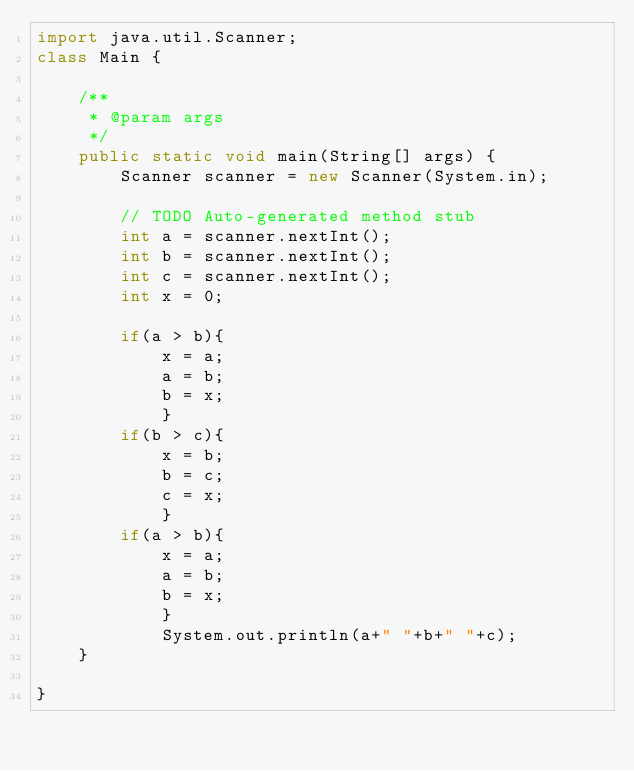<code> <loc_0><loc_0><loc_500><loc_500><_Java_>import java.util.Scanner;
class Main {
          
    /**
     * @param args
     */
    public static void main(String[] args) {
        Scanner scanner = new Scanner(System.in);
              
        // TODO Auto-generated method stub
        int a = scanner.nextInt();
        int b = scanner.nextInt();
        int c = scanner.nextInt();
        int x = 0;
              
        if(a > b){
            x = a;
            a = b;
            b = x;
            }
        if(b > c){
            x = b;
            b = c;
            c = x;
            }
        if(a > b){
            x = a;
            a = b;
            b = x;
            }
            System.out.println(a+" "+b+" "+c);
    }
      
}</code> 